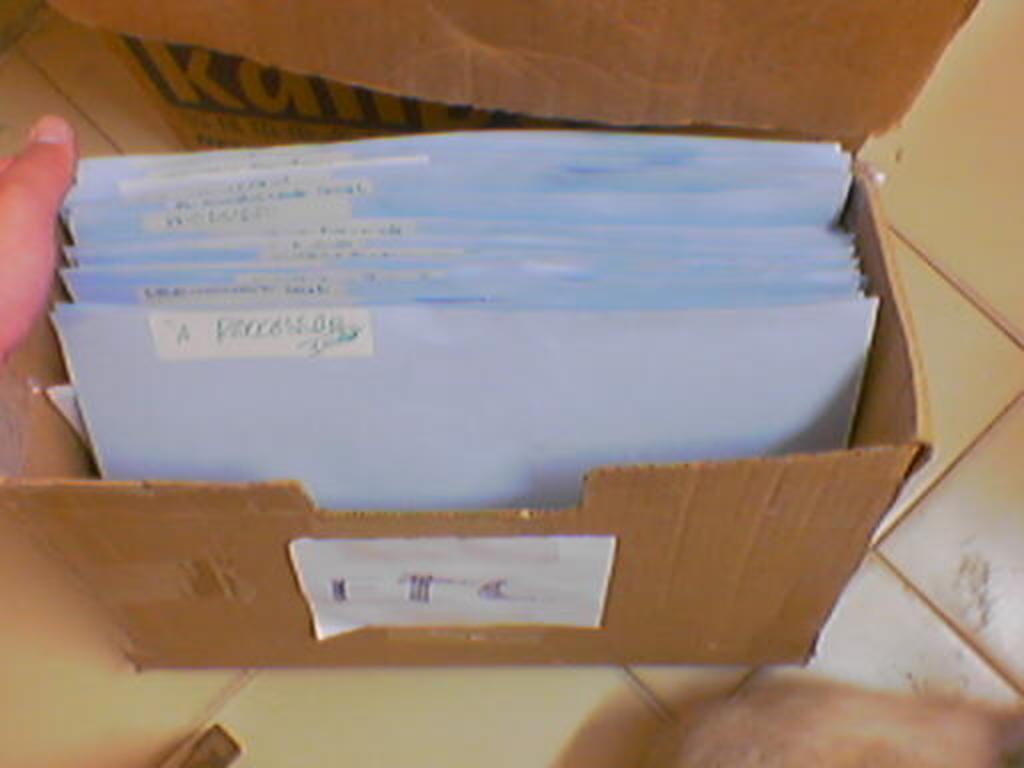In one or two sentences, can you explain what this image depicts? In this image there is a cardboard box having few papers in it. Left side there is a person hand visible. Cardboard box is kept on the floor. 